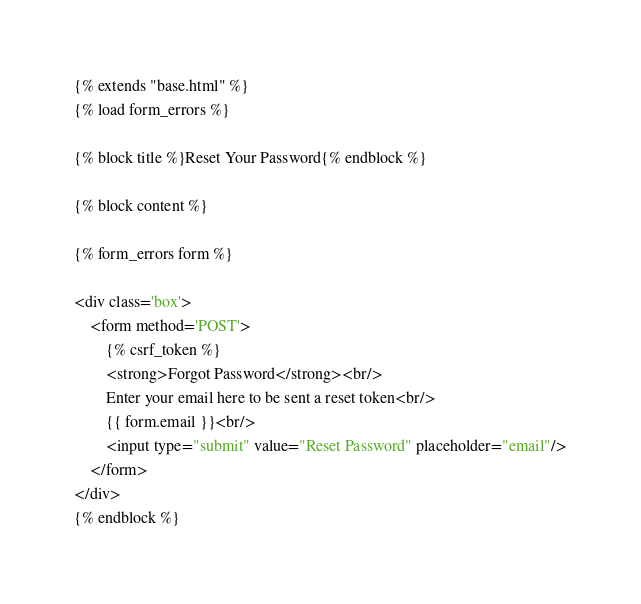<code> <loc_0><loc_0><loc_500><loc_500><_HTML_>{% extends "base.html" %}
{% load form_errors %}

{% block title %}Reset Your Password{% endblock %}

{% block content %}

{% form_errors form %}

<div class='box'>
    <form method='POST'>
        {% csrf_token %}
        <strong>Forgot Password</strong><br/>
        Enter your email here to be sent a reset token<br/>
        {{ form.email }}<br/>
        <input type="submit" value="Reset Password" placeholder="email"/>
    </form>
</div>
{% endblock %}
</code> 